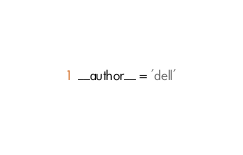<code> <loc_0><loc_0><loc_500><loc_500><_Python_>__author__ = 'dell'
</code> 